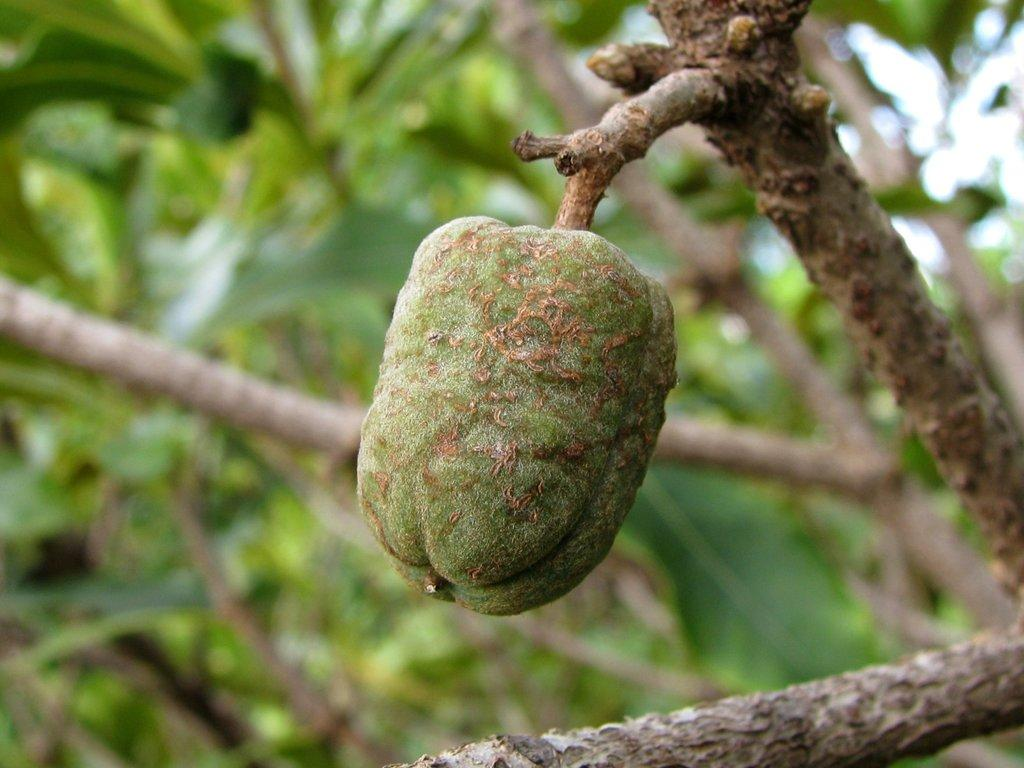What is hanging from the tree in the image? There is a fruit hanging on the stem of a tree in the image. Can you describe the fruit in more detail? Unfortunately, the image does not provide enough detail to describe the fruit further. What is the tree's role in the image? The tree is providing support for the fruit by holding it on its stem. What type of rod can be seen expanding and crushing the fruit in the image? There is no rod present in the image, nor is there any indication of the fruit being crushed or expanded. 